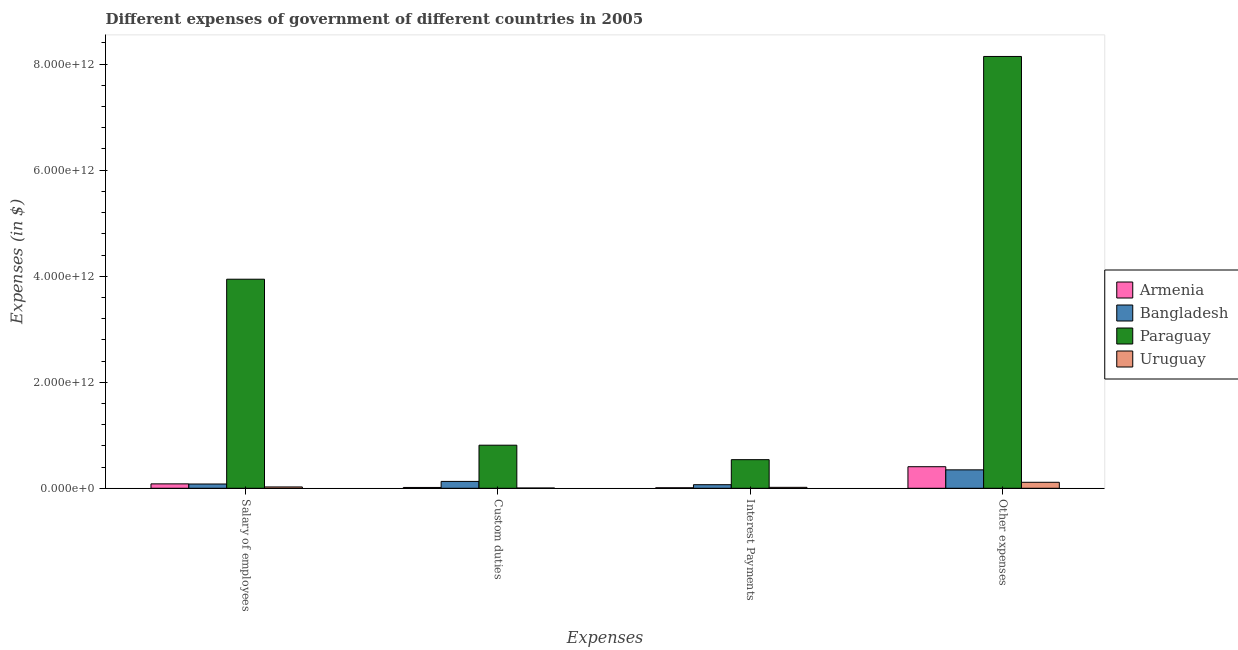Are the number of bars per tick equal to the number of legend labels?
Provide a succinct answer. Yes. Are the number of bars on each tick of the X-axis equal?
Provide a short and direct response. Yes. What is the label of the 1st group of bars from the left?
Make the answer very short. Salary of employees. What is the amount spent on other expenses in Bangladesh?
Offer a terse response. 3.48e+11. Across all countries, what is the maximum amount spent on salary of employees?
Ensure brevity in your answer.  3.94e+12. Across all countries, what is the minimum amount spent on interest payments?
Make the answer very short. 9.93e+09. In which country was the amount spent on interest payments maximum?
Give a very brief answer. Paraguay. In which country was the amount spent on salary of employees minimum?
Provide a succinct answer. Uruguay. What is the total amount spent on interest payments in the graph?
Offer a terse response. 6.35e+11. What is the difference between the amount spent on interest payments in Armenia and that in Uruguay?
Ensure brevity in your answer.  -8.01e+09. What is the difference between the amount spent on interest payments in Armenia and the amount spent on other expenses in Uruguay?
Your answer should be compact. -1.03e+11. What is the average amount spent on salary of employees per country?
Offer a very short reply. 1.03e+12. What is the difference between the amount spent on custom duties and amount spent on salary of employees in Paraguay?
Your answer should be compact. -3.13e+12. What is the ratio of the amount spent on custom duties in Uruguay to that in Armenia?
Give a very brief answer. 0.34. Is the amount spent on salary of employees in Armenia less than that in Bangladesh?
Provide a short and direct response. No. Is the difference between the amount spent on interest payments in Armenia and Uruguay greater than the difference between the amount spent on salary of employees in Armenia and Uruguay?
Offer a terse response. No. What is the difference between the highest and the second highest amount spent on salary of employees?
Give a very brief answer. 3.86e+12. What is the difference between the highest and the lowest amount spent on other expenses?
Offer a terse response. 8.03e+12. Is the sum of the amount spent on interest payments in Uruguay and Bangladesh greater than the maximum amount spent on custom duties across all countries?
Give a very brief answer. No. What does the 1st bar from the left in Custom duties represents?
Your response must be concise. Armenia. What does the 3rd bar from the right in Interest Payments represents?
Your response must be concise. Bangladesh. Is it the case that in every country, the sum of the amount spent on salary of employees and amount spent on custom duties is greater than the amount spent on interest payments?
Provide a short and direct response. Yes. What is the difference between two consecutive major ticks on the Y-axis?
Provide a short and direct response. 2.00e+12. Does the graph contain any zero values?
Your answer should be compact. No. Where does the legend appear in the graph?
Ensure brevity in your answer.  Center right. How are the legend labels stacked?
Make the answer very short. Vertical. What is the title of the graph?
Offer a terse response. Different expenses of government of different countries in 2005. What is the label or title of the X-axis?
Your answer should be compact. Expenses. What is the label or title of the Y-axis?
Make the answer very short. Expenses (in $). What is the Expenses (in $) in Armenia in Salary of employees?
Offer a very short reply. 8.32e+1. What is the Expenses (in $) in Bangladesh in Salary of employees?
Your answer should be compact. 8.07e+1. What is the Expenses (in $) of Paraguay in Salary of employees?
Your response must be concise. 3.94e+12. What is the Expenses (in $) in Uruguay in Salary of employees?
Provide a succinct answer. 2.52e+1. What is the Expenses (in $) of Armenia in Custom duties?
Offer a very short reply. 1.54e+1. What is the Expenses (in $) in Bangladesh in Custom duties?
Give a very brief answer. 1.30e+11. What is the Expenses (in $) of Paraguay in Custom duties?
Give a very brief answer. 8.13e+11. What is the Expenses (in $) of Uruguay in Custom duties?
Provide a short and direct response. 5.20e+09. What is the Expenses (in $) in Armenia in Interest Payments?
Give a very brief answer. 9.93e+09. What is the Expenses (in $) in Bangladesh in Interest Payments?
Provide a succinct answer. 6.76e+1. What is the Expenses (in $) of Paraguay in Interest Payments?
Your answer should be very brief. 5.40e+11. What is the Expenses (in $) in Uruguay in Interest Payments?
Offer a very short reply. 1.79e+1. What is the Expenses (in $) of Armenia in Other expenses?
Your response must be concise. 4.07e+11. What is the Expenses (in $) of Bangladesh in Other expenses?
Ensure brevity in your answer.  3.48e+11. What is the Expenses (in $) of Paraguay in Other expenses?
Ensure brevity in your answer.  8.15e+12. What is the Expenses (in $) of Uruguay in Other expenses?
Your answer should be compact. 1.13e+11. Across all Expenses, what is the maximum Expenses (in $) in Armenia?
Keep it short and to the point. 4.07e+11. Across all Expenses, what is the maximum Expenses (in $) of Bangladesh?
Your answer should be very brief. 3.48e+11. Across all Expenses, what is the maximum Expenses (in $) of Paraguay?
Ensure brevity in your answer.  8.15e+12. Across all Expenses, what is the maximum Expenses (in $) in Uruguay?
Your answer should be very brief. 1.13e+11. Across all Expenses, what is the minimum Expenses (in $) in Armenia?
Ensure brevity in your answer.  9.93e+09. Across all Expenses, what is the minimum Expenses (in $) of Bangladesh?
Ensure brevity in your answer.  6.76e+1. Across all Expenses, what is the minimum Expenses (in $) of Paraguay?
Keep it short and to the point. 5.40e+11. Across all Expenses, what is the minimum Expenses (in $) in Uruguay?
Give a very brief answer. 5.20e+09. What is the total Expenses (in $) in Armenia in the graph?
Offer a very short reply. 5.16e+11. What is the total Expenses (in $) of Bangladesh in the graph?
Your response must be concise. 6.26e+11. What is the total Expenses (in $) of Paraguay in the graph?
Provide a succinct answer. 1.34e+13. What is the total Expenses (in $) of Uruguay in the graph?
Provide a short and direct response. 1.61e+11. What is the difference between the Expenses (in $) in Armenia in Salary of employees and that in Custom duties?
Provide a short and direct response. 6.78e+1. What is the difference between the Expenses (in $) in Bangladesh in Salary of employees and that in Custom duties?
Ensure brevity in your answer.  -4.88e+1. What is the difference between the Expenses (in $) in Paraguay in Salary of employees and that in Custom duties?
Give a very brief answer. 3.13e+12. What is the difference between the Expenses (in $) of Uruguay in Salary of employees and that in Custom duties?
Give a very brief answer. 2.00e+1. What is the difference between the Expenses (in $) in Armenia in Salary of employees and that in Interest Payments?
Keep it short and to the point. 7.33e+1. What is the difference between the Expenses (in $) in Bangladesh in Salary of employees and that in Interest Payments?
Give a very brief answer. 1.32e+1. What is the difference between the Expenses (in $) in Paraguay in Salary of employees and that in Interest Payments?
Provide a succinct answer. 3.40e+12. What is the difference between the Expenses (in $) of Uruguay in Salary of employees and that in Interest Payments?
Offer a very short reply. 7.26e+09. What is the difference between the Expenses (in $) of Armenia in Salary of employees and that in Other expenses?
Provide a succinct answer. -3.24e+11. What is the difference between the Expenses (in $) of Bangladesh in Salary of employees and that in Other expenses?
Provide a succinct answer. -2.67e+11. What is the difference between the Expenses (in $) in Paraguay in Salary of employees and that in Other expenses?
Offer a very short reply. -4.20e+12. What is the difference between the Expenses (in $) in Uruguay in Salary of employees and that in Other expenses?
Offer a terse response. -8.77e+1. What is the difference between the Expenses (in $) of Armenia in Custom duties and that in Interest Payments?
Your response must be concise. 5.48e+09. What is the difference between the Expenses (in $) in Bangladesh in Custom duties and that in Interest Payments?
Your response must be concise. 6.20e+1. What is the difference between the Expenses (in $) in Paraguay in Custom duties and that in Interest Payments?
Your answer should be compact. 2.73e+11. What is the difference between the Expenses (in $) of Uruguay in Custom duties and that in Interest Payments?
Give a very brief answer. -1.28e+1. What is the difference between the Expenses (in $) in Armenia in Custom duties and that in Other expenses?
Your answer should be compact. -3.92e+11. What is the difference between the Expenses (in $) of Bangladesh in Custom duties and that in Other expenses?
Your answer should be very brief. -2.18e+11. What is the difference between the Expenses (in $) in Paraguay in Custom duties and that in Other expenses?
Your response must be concise. -7.33e+12. What is the difference between the Expenses (in $) of Uruguay in Custom duties and that in Other expenses?
Ensure brevity in your answer.  -1.08e+11. What is the difference between the Expenses (in $) of Armenia in Interest Payments and that in Other expenses?
Make the answer very short. -3.97e+11. What is the difference between the Expenses (in $) of Bangladesh in Interest Payments and that in Other expenses?
Provide a short and direct response. -2.80e+11. What is the difference between the Expenses (in $) in Paraguay in Interest Payments and that in Other expenses?
Your answer should be compact. -7.61e+12. What is the difference between the Expenses (in $) of Uruguay in Interest Payments and that in Other expenses?
Offer a very short reply. -9.49e+1. What is the difference between the Expenses (in $) of Armenia in Salary of employees and the Expenses (in $) of Bangladesh in Custom duties?
Your answer should be compact. -4.63e+1. What is the difference between the Expenses (in $) in Armenia in Salary of employees and the Expenses (in $) in Paraguay in Custom duties?
Your answer should be very brief. -7.29e+11. What is the difference between the Expenses (in $) of Armenia in Salary of employees and the Expenses (in $) of Uruguay in Custom duties?
Your response must be concise. 7.80e+1. What is the difference between the Expenses (in $) in Bangladesh in Salary of employees and the Expenses (in $) in Paraguay in Custom duties?
Offer a terse response. -7.32e+11. What is the difference between the Expenses (in $) of Bangladesh in Salary of employees and the Expenses (in $) of Uruguay in Custom duties?
Provide a short and direct response. 7.55e+1. What is the difference between the Expenses (in $) in Paraguay in Salary of employees and the Expenses (in $) in Uruguay in Custom duties?
Provide a short and direct response. 3.94e+12. What is the difference between the Expenses (in $) in Armenia in Salary of employees and the Expenses (in $) in Bangladesh in Interest Payments?
Your answer should be compact. 1.57e+1. What is the difference between the Expenses (in $) of Armenia in Salary of employees and the Expenses (in $) of Paraguay in Interest Payments?
Offer a terse response. -4.56e+11. What is the difference between the Expenses (in $) of Armenia in Salary of employees and the Expenses (in $) of Uruguay in Interest Payments?
Your response must be concise. 6.53e+1. What is the difference between the Expenses (in $) in Bangladesh in Salary of employees and the Expenses (in $) in Paraguay in Interest Payments?
Provide a short and direct response. -4.59e+11. What is the difference between the Expenses (in $) of Bangladesh in Salary of employees and the Expenses (in $) of Uruguay in Interest Payments?
Make the answer very short. 6.28e+1. What is the difference between the Expenses (in $) of Paraguay in Salary of employees and the Expenses (in $) of Uruguay in Interest Payments?
Ensure brevity in your answer.  3.93e+12. What is the difference between the Expenses (in $) in Armenia in Salary of employees and the Expenses (in $) in Bangladesh in Other expenses?
Offer a very short reply. -2.65e+11. What is the difference between the Expenses (in $) in Armenia in Salary of employees and the Expenses (in $) in Paraguay in Other expenses?
Provide a short and direct response. -8.06e+12. What is the difference between the Expenses (in $) in Armenia in Salary of employees and the Expenses (in $) in Uruguay in Other expenses?
Ensure brevity in your answer.  -2.96e+1. What is the difference between the Expenses (in $) of Bangladesh in Salary of employees and the Expenses (in $) of Paraguay in Other expenses?
Your response must be concise. -8.06e+12. What is the difference between the Expenses (in $) of Bangladesh in Salary of employees and the Expenses (in $) of Uruguay in Other expenses?
Offer a terse response. -3.21e+1. What is the difference between the Expenses (in $) in Paraguay in Salary of employees and the Expenses (in $) in Uruguay in Other expenses?
Offer a terse response. 3.83e+12. What is the difference between the Expenses (in $) of Armenia in Custom duties and the Expenses (in $) of Bangladesh in Interest Payments?
Your answer should be very brief. -5.22e+1. What is the difference between the Expenses (in $) in Armenia in Custom duties and the Expenses (in $) in Paraguay in Interest Payments?
Ensure brevity in your answer.  -5.24e+11. What is the difference between the Expenses (in $) of Armenia in Custom duties and the Expenses (in $) of Uruguay in Interest Payments?
Your response must be concise. -2.54e+09. What is the difference between the Expenses (in $) of Bangladesh in Custom duties and the Expenses (in $) of Paraguay in Interest Payments?
Give a very brief answer. -4.10e+11. What is the difference between the Expenses (in $) of Bangladesh in Custom duties and the Expenses (in $) of Uruguay in Interest Payments?
Keep it short and to the point. 1.12e+11. What is the difference between the Expenses (in $) in Paraguay in Custom duties and the Expenses (in $) in Uruguay in Interest Payments?
Provide a short and direct response. 7.95e+11. What is the difference between the Expenses (in $) in Armenia in Custom duties and the Expenses (in $) in Bangladesh in Other expenses?
Offer a terse response. -3.32e+11. What is the difference between the Expenses (in $) in Armenia in Custom duties and the Expenses (in $) in Paraguay in Other expenses?
Keep it short and to the point. -8.13e+12. What is the difference between the Expenses (in $) of Armenia in Custom duties and the Expenses (in $) of Uruguay in Other expenses?
Give a very brief answer. -9.75e+1. What is the difference between the Expenses (in $) of Bangladesh in Custom duties and the Expenses (in $) of Paraguay in Other expenses?
Your answer should be very brief. -8.02e+12. What is the difference between the Expenses (in $) of Bangladesh in Custom duties and the Expenses (in $) of Uruguay in Other expenses?
Offer a terse response. 1.67e+1. What is the difference between the Expenses (in $) in Paraguay in Custom duties and the Expenses (in $) in Uruguay in Other expenses?
Your answer should be compact. 7.00e+11. What is the difference between the Expenses (in $) in Armenia in Interest Payments and the Expenses (in $) in Bangladesh in Other expenses?
Your response must be concise. -3.38e+11. What is the difference between the Expenses (in $) in Armenia in Interest Payments and the Expenses (in $) in Paraguay in Other expenses?
Give a very brief answer. -8.14e+12. What is the difference between the Expenses (in $) in Armenia in Interest Payments and the Expenses (in $) in Uruguay in Other expenses?
Your response must be concise. -1.03e+11. What is the difference between the Expenses (in $) of Bangladesh in Interest Payments and the Expenses (in $) of Paraguay in Other expenses?
Offer a terse response. -8.08e+12. What is the difference between the Expenses (in $) in Bangladesh in Interest Payments and the Expenses (in $) in Uruguay in Other expenses?
Give a very brief answer. -4.53e+1. What is the difference between the Expenses (in $) in Paraguay in Interest Payments and the Expenses (in $) in Uruguay in Other expenses?
Provide a short and direct response. 4.27e+11. What is the average Expenses (in $) in Armenia per Expenses?
Offer a very short reply. 1.29e+11. What is the average Expenses (in $) of Bangladesh per Expenses?
Ensure brevity in your answer.  1.56e+11. What is the average Expenses (in $) in Paraguay per Expenses?
Keep it short and to the point. 3.36e+12. What is the average Expenses (in $) of Uruguay per Expenses?
Provide a succinct answer. 4.03e+1. What is the difference between the Expenses (in $) of Armenia and Expenses (in $) of Bangladesh in Salary of employees?
Your answer should be compact. 2.51e+09. What is the difference between the Expenses (in $) of Armenia and Expenses (in $) of Paraguay in Salary of employees?
Provide a short and direct response. -3.86e+12. What is the difference between the Expenses (in $) in Armenia and Expenses (in $) in Uruguay in Salary of employees?
Your answer should be very brief. 5.80e+1. What is the difference between the Expenses (in $) in Bangladesh and Expenses (in $) in Paraguay in Salary of employees?
Give a very brief answer. -3.86e+12. What is the difference between the Expenses (in $) in Bangladesh and Expenses (in $) in Uruguay in Salary of employees?
Keep it short and to the point. 5.55e+1. What is the difference between the Expenses (in $) of Paraguay and Expenses (in $) of Uruguay in Salary of employees?
Offer a very short reply. 3.92e+12. What is the difference between the Expenses (in $) in Armenia and Expenses (in $) in Bangladesh in Custom duties?
Give a very brief answer. -1.14e+11. What is the difference between the Expenses (in $) in Armenia and Expenses (in $) in Paraguay in Custom duties?
Your answer should be compact. -7.97e+11. What is the difference between the Expenses (in $) in Armenia and Expenses (in $) in Uruguay in Custom duties?
Give a very brief answer. 1.02e+1. What is the difference between the Expenses (in $) of Bangladesh and Expenses (in $) of Paraguay in Custom duties?
Your answer should be compact. -6.83e+11. What is the difference between the Expenses (in $) of Bangladesh and Expenses (in $) of Uruguay in Custom duties?
Provide a short and direct response. 1.24e+11. What is the difference between the Expenses (in $) in Paraguay and Expenses (in $) in Uruguay in Custom duties?
Provide a succinct answer. 8.08e+11. What is the difference between the Expenses (in $) in Armenia and Expenses (in $) in Bangladesh in Interest Payments?
Make the answer very short. -5.76e+1. What is the difference between the Expenses (in $) of Armenia and Expenses (in $) of Paraguay in Interest Payments?
Ensure brevity in your answer.  -5.30e+11. What is the difference between the Expenses (in $) of Armenia and Expenses (in $) of Uruguay in Interest Payments?
Your answer should be compact. -8.01e+09. What is the difference between the Expenses (in $) in Bangladesh and Expenses (in $) in Paraguay in Interest Payments?
Ensure brevity in your answer.  -4.72e+11. What is the difference between the Expenses (in $) of Bangladesh and Expenses (in $) of Uruguay in Interest Payments?
Provide a short and direct response. 4.96e+1. What is the difference between the Expenses (in $) in Paraguay and Expenses (in $) in Uruguay in Interest Payments?
Your answer should be very brief. 5.22e+11. What is the difference between the Expenses (in $) in Armenia and Expenses (in $) in Bangladesh in Other expenses?
Provide a succinct answer. 5.93e+1. What is the difference between the Expenses (in $) of Armenia and Expenses (in $) of Paraguay in Other expenses?
Offer a very short reply. -7.74e+12. What is the difference between the Expenses (in $) of Armenia and Expenses (in $) of Uruguay in Other expenses?
Make the answer very short. 2.94e+11. What is the difference between the Expenses (in $) in Bangladesh and Expenses (in $) in Paraguay in Other expenses?
Your answer should be very brief. -7.80e+12. What is the difference between the Expenses (in $) of Bangladesh and Expenses (in $) of Uruguay in Other expenses?
Keep it short and to the point. 2.35e+11. What is the difference between the Expenses (in $) in Paraguay and Expenses (in $) in Uruguay in Other expenses?
Your answer should be very brief. 8.03e+12. What is the ratio of the Expenses (in $) of Armenia in Salary of employees to that in Custom duties?
Offer a very short reply. 5.4. What is the ratio of the Expenses (in $) in Bangladesh in Salary of employees to that in Custom duties?
Make the answer very short. 0.62. What is the ratio of the Expenses (in $) of Paraguay in Salary of employees to that in Custom duties?
Provide a succinct answer. 4.85. What is the ratio of the Expenses (in $) in Uruguay in Salary of employees to that in Custom duties?
Offer a terse response. 4.85. What is the ratio of the Expenses (in $) of Armenia in Salary of employees to that in Interest Payments?
Offer a very short reply. 8.38. What is the ratio of the Expenses (in $) of Bangladesh in Salary of employees to that in Interest Payments?
Give a very brief answer. 1.19. What is the ratio of the Expenses (in $) in Paraguay in Salary of employees to that in Interest Payments?
Keep it short and to the point. 7.31. What is the ratio of the Expenses (in $) in Uruguay in Salary of employees to that in Interest Payments?
Give a very brief answer. 1.4. What is the ratio of the Expenses (in $) of Armenia in Salary of employees to that in Other expenses?
Provide a succinct answer. 0.2. What is the ratio of the Expenses (in $) in Bangladesh in Salary of employees to that in Other expenses?
Offer a very short reply. 0.23. What is the ratio of the Expenses (in $) of Paraguay in Salary of employees to that in Other expenses?
Offer a terse response. 0.48. What is the ratio of the Expenses (in $) in Uruguay in Salary of employees to that in Other expenses?
Your answer should be compact. 0.22. What is the ratio of the Expenses (in $) in Armenia in Custom duties to that in Interest Payments?
Offer a terse response. 1.55. What is the ratio of the Expenses (in $) of Bangladesh in Custom duties to that in Interest Payments?
Offer a very short reply. 1.92. What is the ratio of the Expenses (in $) of Paraguay in Custom duties to that in Interest Payments?
Your response must be concise. 1.51. What is the ratio of the Expenses (in $) in Uruguay in Custom duties to that in Interest Payments?
Make the answer very short. 0.29. What is the ratio of the Expenses (in $) of Armenia in Custom duties to that in Other expenses?
Make the answer very short. 0.04. What is the ratio of the Expenses (in $) of Bangladesh in Custom duties to that in Other expenses?
Ensure brevity in your answer.  0.37. What is the ratio of the Expenses (in $) of Paraguay in Custom duties to that in Other expenses?
Provide a short and direct response. 0.1. What is the ratio of the Expenses (in $) of Uruguay in Custom duties to that in Other expenses?
Offer a very short reply. 0.05. What is the ratio of the Expenses (in $) of Armenia in Interest Payments to that in Other expenses?
Ensure brevity in your answer.  0.02. What is the ratio of the Expenses (in $) of Bangladesh in Interest Payments to that in Other expenses?
Make the answer very short. 0.19. What is the ratio of the Expenses (in $) of Paraguay in Interest Payments to that in Other expenses?
Provide a succinct answer. 0.07. What is the ratio of the Expenses (in $) in Uruguay in Interest Payments to that in Other expenses?
Offer a very short reply. 0.16. What is the difference between the highest and the second highest Expenses (in $) in Armenia?
Your answer should be very brief. 3.24e+11. What is the difference between the highest and the second highest Expenses (in $) of Bangladesh?
Your answer should be very brief. 2.18e+11. What is the difference between the highest and the second highest Expenses (in $) of Paraguay?
Your answer should be compact. 4.20e+12. What is the difference between the highest and the second highest Expenses (in $) of Uruguay?
Offer a terse response. 8.77e+1. What is the difference between the highest and the lowest Expenses (in $) in Armenia?
Make the answer very short. 3.97e+11. What is the difference between the highest and the lowest Expenses (in $) in Bangladesh?
Provide a succinct answer. 2.80e+11. What is the difference between the highest and the lowest Expenses (in $) in Paraguay?
Provide a short and direct response. 7.61e+12. What is the difference between the highest and the lowest Expenses (in $) in Uruguay?
Give a very brief answer. 1.08e+11. 